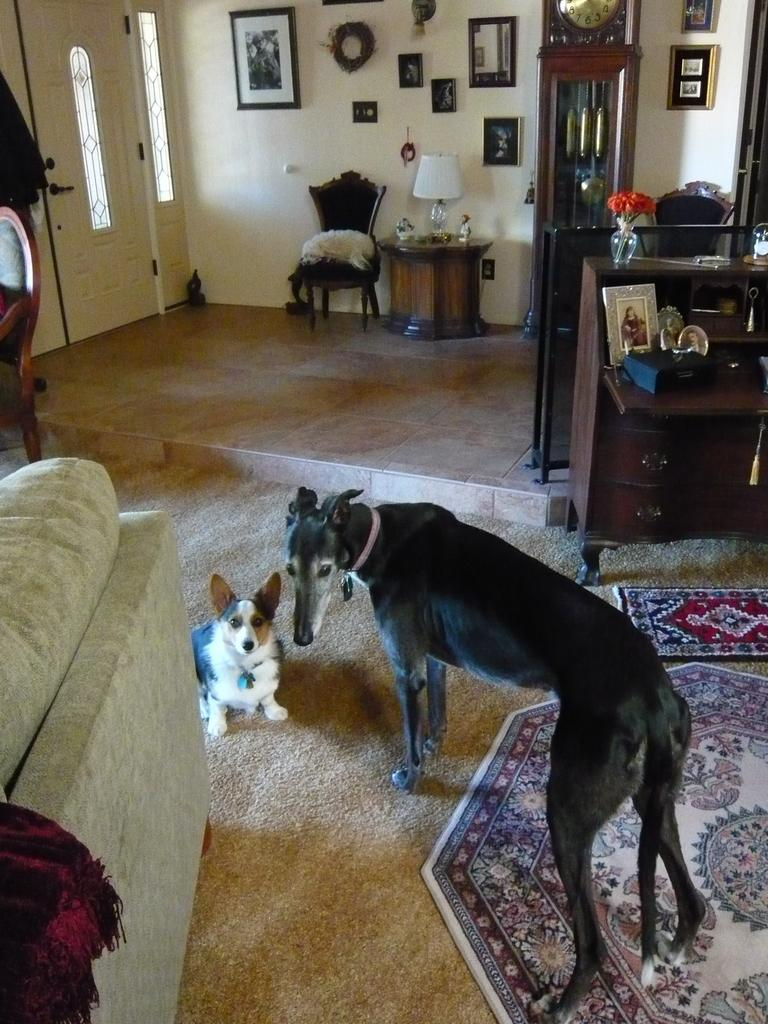How many dogs are present in the image? There are two dogs on the floor in the image. What type of furniture can be seen in the image? There is a wooden table and a chair in the image. Is there any decorative item visible in the image? Yes, there is a photo frame fixed to a wall in the image. How can one enter the room depicted in the image? There is a door in the image, which is used to enter the room. Can you see a mountain in the background of the image? No, there is no mountain visible in the image. 